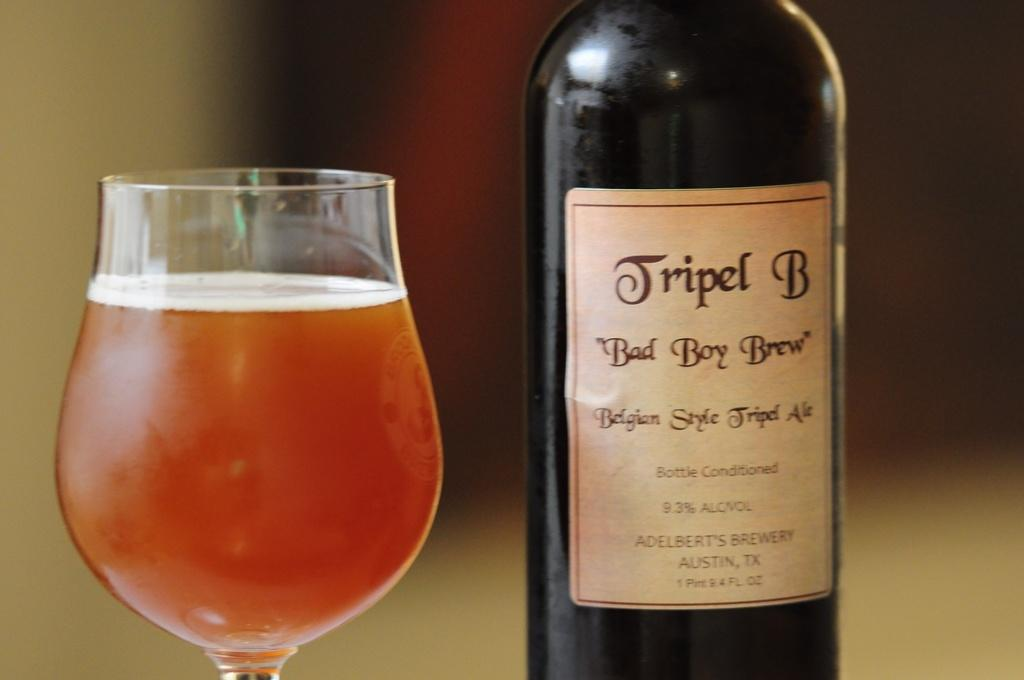<image>
Describe the image concisely. a glass and bottle of Tripel B ale displayed 